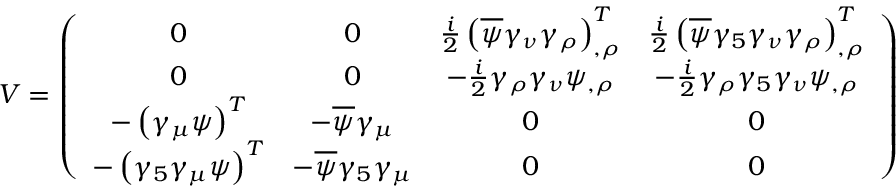<formula> <loc_0><loc_0><loc_500><loc_500>V = \left ( \begin{array} { c c c c } { 0 } & { 0 } & { { \frac { i } { 2 } \left ( \overline { \psi } \gamma _ { \nu } \gamma _ { \rho } \right ) _ { , \rho } ^ { T } } } & { { \frac { i } { 2 } \left ( \overline { \psi } \gamma _ { 5 } \gamma _ { \nu } \gamma _ { \rho } \right ) _ { , \rho } ^ { T } } } \\ { 0 } & { 0 } & { { - \frac { i } { 2 } \gamma _ { \rho } \gamma _ { \nu } \psi _ { , \rho } } } & { { - \frac { i } { 2 } \gamma _ { \rho } \gamma _ { 5 } \gamma _ { \nu } \psi _ { , \rho } } } \\ { { - \left ( \gamma _ { \mu } \psi \right ) ^ { T } } } & { { - \overline { \psi } \gamma _ { \mu } } } & { 0 } & { 0 } \\ { { - \left ( \gamma _ { 5 } \gamma _ { \mu } \psi \right ) ^ { T } } } & { { - \overline { \psi } \gamma _ { 5 } \gamma _ { \mu } } } & { 0 } & { 0 } \end{array} \right )</formula> 